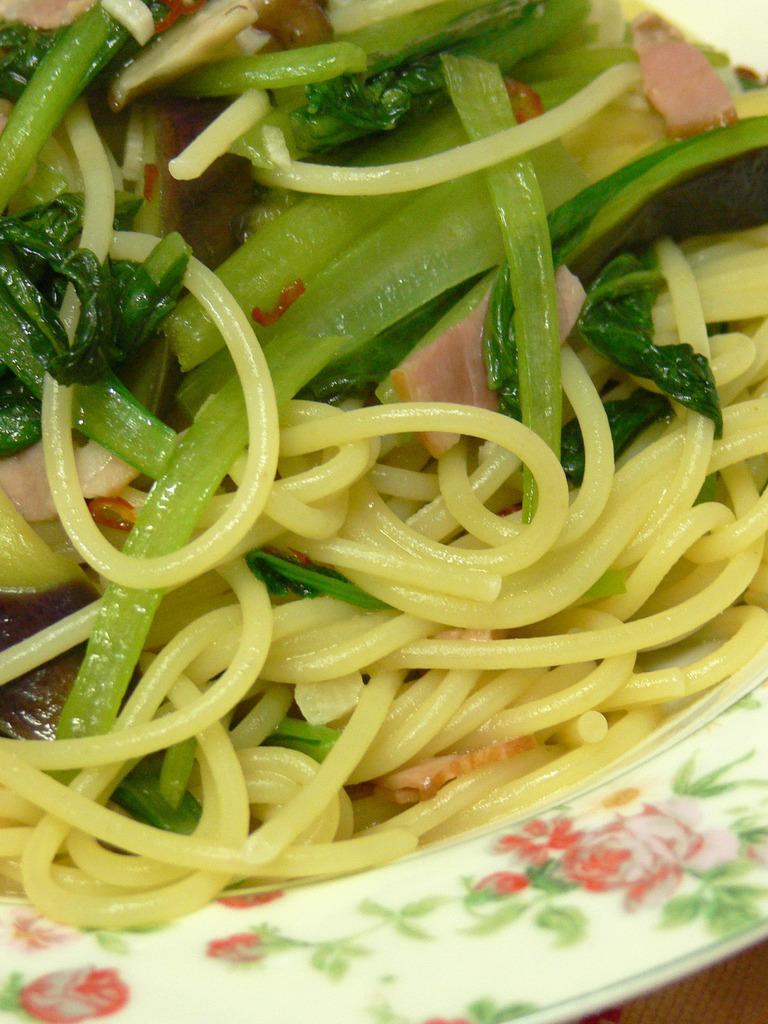How would you summarize this image in a sentence or two? In this image there is a food item on the plate. 